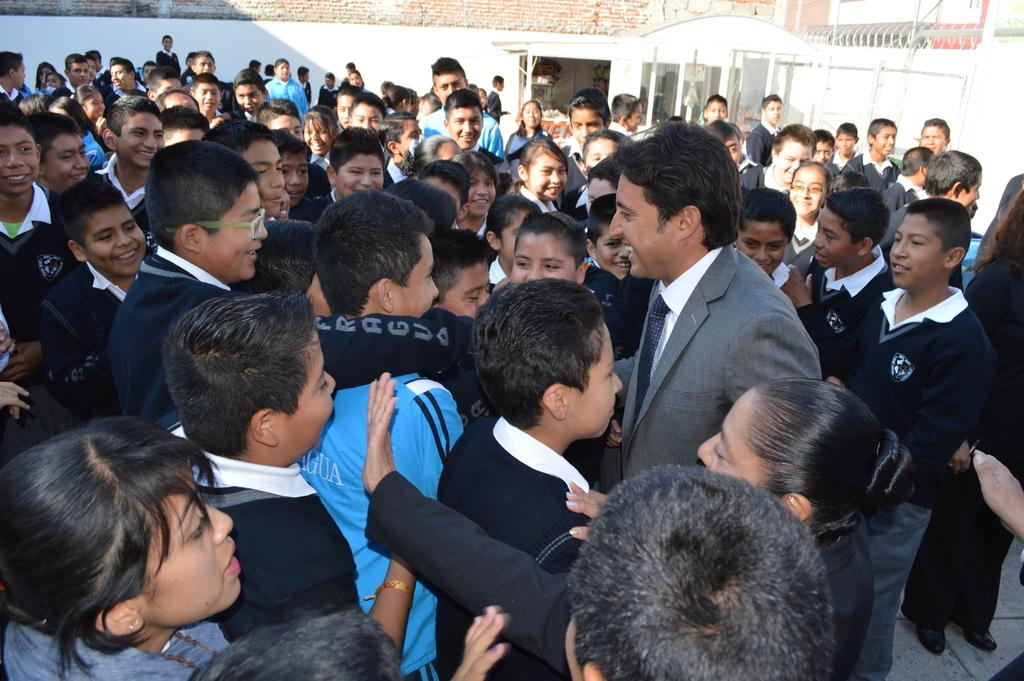What is the main subject of the image? The main subject of the image is a group of people. Where are the people located in the image? The group of people is in the middle of the image. What can be seen at the top of the image? Walls are visible at the top of the image. How many dogs are playing with the doll in the town depicted in the image? There are no dogs, dolls, or towns present in the image; it features a group of people and walls. 